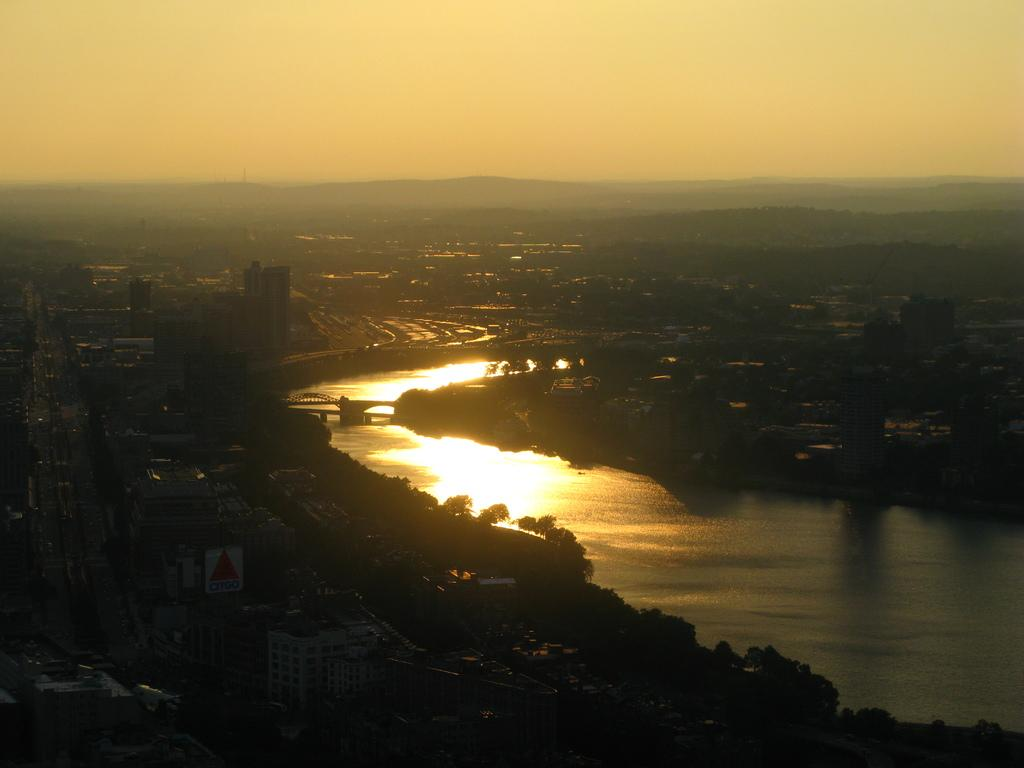What is visible in the image? Water is visible in the image. What can be seen on either side of the water? There are buildings and trees on either side of the water. Where is the market located in the image? There is no market present in the image. What type of rod can be seen in the image? There is no rod present in the image. 